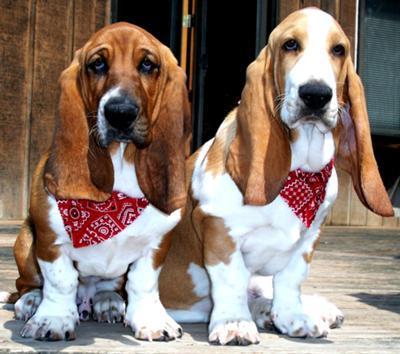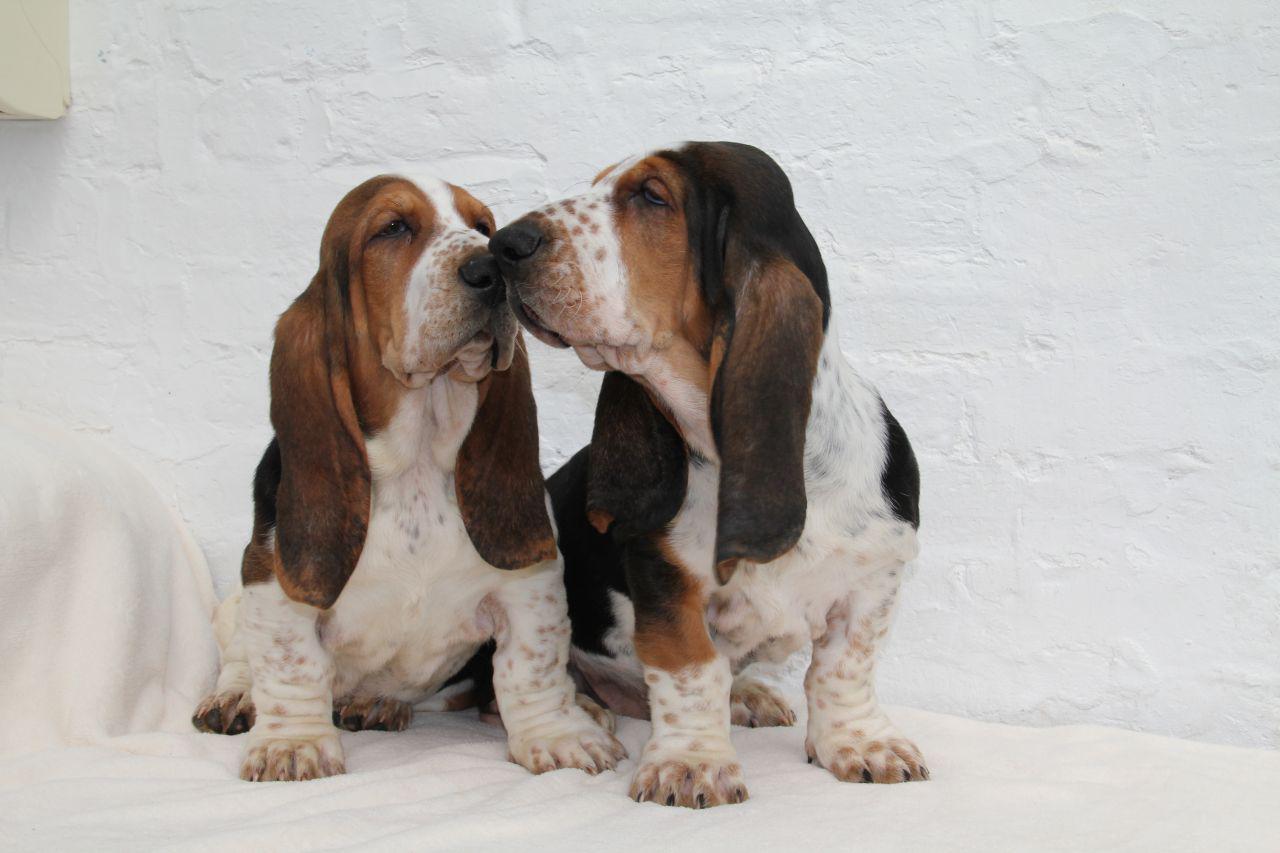The first image is the image on the left, the second image is the image on the right. Considering the images on both sides, is "The right image shows side-by-side basset hounds posed in the grass, and the left image shows one human posed in the grass with at least one basset hound." valid? Answer yes or no. No. The first image is the image on the left, the second image is the image on the right. For the images shown, is this caption "One of the image shows only basset hounds, while the other shows a human with at least one basset hound." true? Answer yes or no. No. 